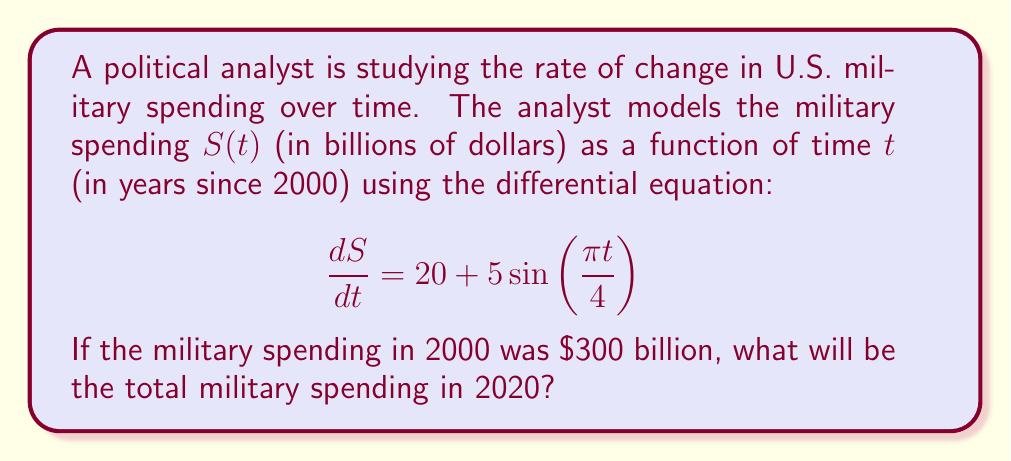Solve this math problem. To solve this problem, we need to integrate the given differential equation and apply the initial condition. Here's a step-by-step approach:

1) The differential equation is:

   $$\frac{dS}{dt} = 20 + 5\sin(\frac{\pi t}{4})$$

2) To find $S(t)$, we integrate both sides:

   $$S(t) = \int (20 + 5\sin(\frac{\pi t}{4})) dt$$

3) Integrating the constant and the sine function:

   $$S(t) = 20t - \frac{20}{\pi/4}\cos(\frac{\pi t}{4}) + C$$

   $$S(t) = 20t - \frac{80}{\pi}\cos(\frac{\pi t}{4}) + C$$

4) Now we use the initial condition: $S(0) = 300$

   $$300 = 20(0) - \frac{80}{\pi}\cos(0) + C$$
   $$300 = -\frac{80}{\pi} + C$$
   $$C = 300 + \frac{80}{\pi}$$

5) Our final function for $S(t)$ is:

   $$S(t) = 20t - \frac{80}{\pi}\cos(\frac{\pi t}{4}) + 300 + \frac{80}{\pi}$$

6) To find the spending in 2020, we calculate $S(20)$:

   $$S(20) = 20(20) - \frac{80}{\pi}\cos(\frac{\pi (20)}{4}) + 300 + \frac{80}{\pi}$$
   $$S(20) = 400 - \frac{80}{\pi}\cos(5\pi) + 300 + \frac{80}{\pi}$$
   $$S(20) = 700 + \frac{80}{\pi}(1-\cos(5\pi))$$
   $$S(20) = 700 + \frac{160}{\pi}$$

7) Evaluating this expression:

   $$S(20) \approx 750.93$$ billion dollars
Answer: The total military spending in 2020 will be approximately $750.93 billion. 